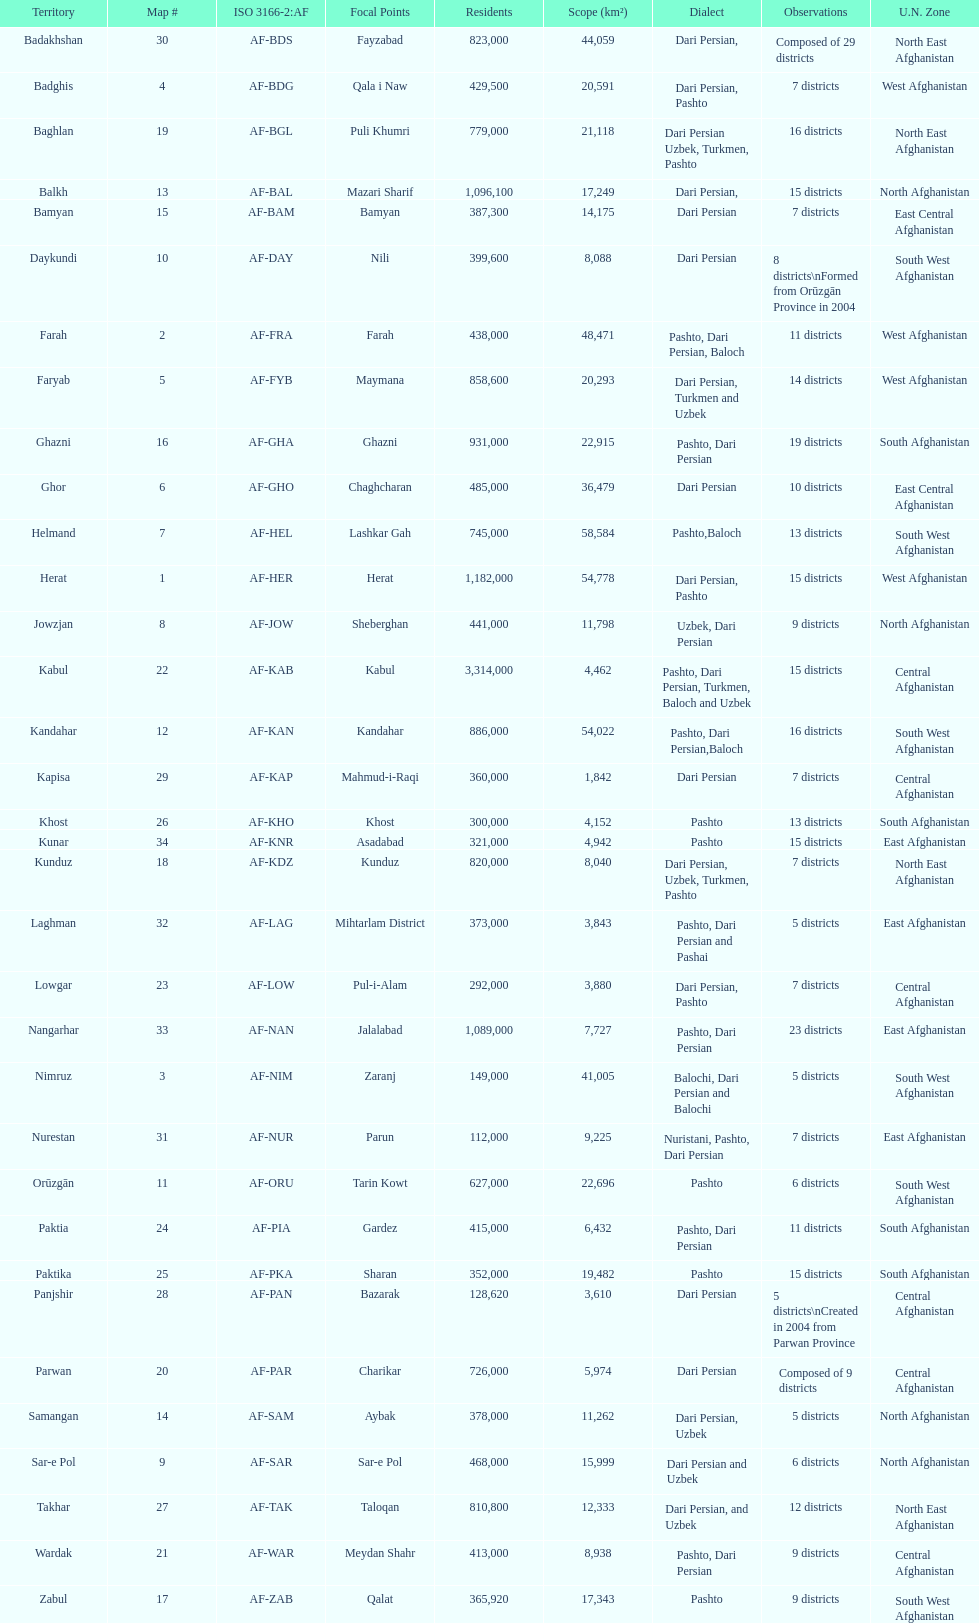How many provinces in afghanistan speak dari persian? 28. 